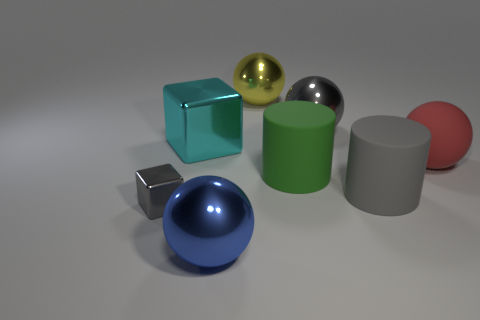Subtract all blue spheres. How many spheres are left? 3 Subtract all yellow metal balls. How many balls are left? 3 Add 1 green rubber objects. How many objects exist? 9 Subtract all purple balls. Subtract all brown cylinders. How many balls are left? 4 Subtract all cylinders. How many objects are left? 6 Subtract all small gray things. Subtract all large yellow balls. How many objects are left? 6 Add 1 small gray objects. How many small gray objects are left? 2 Add 2 gray balls. How many gray balls exist? 3 Subtract 0 blue cubes. How many objects are left? 8 